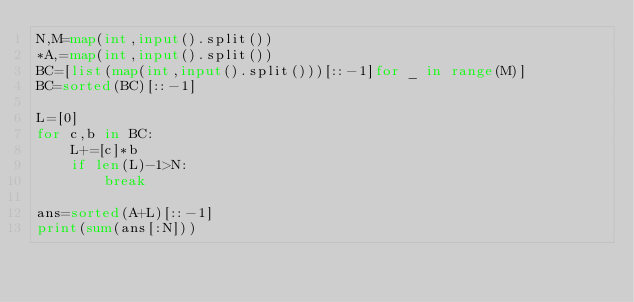Convert code to text. <code><loc_0><loc_0><loc_500><loc_500><_Python_>N,M=map(int,input().split())
*A,=map(int,input().split())
BC=[list(map(int,input().split()))[::-1]for _ in range(M)]
BC=sorted(BC)[::-1]

L=[0]
for c,b in BC:
    L+=[c]*b
    if len(L)-1>N:
        break

ans=sorted(A+L)[::-1]
print(sum(ans[:N]))</code> 